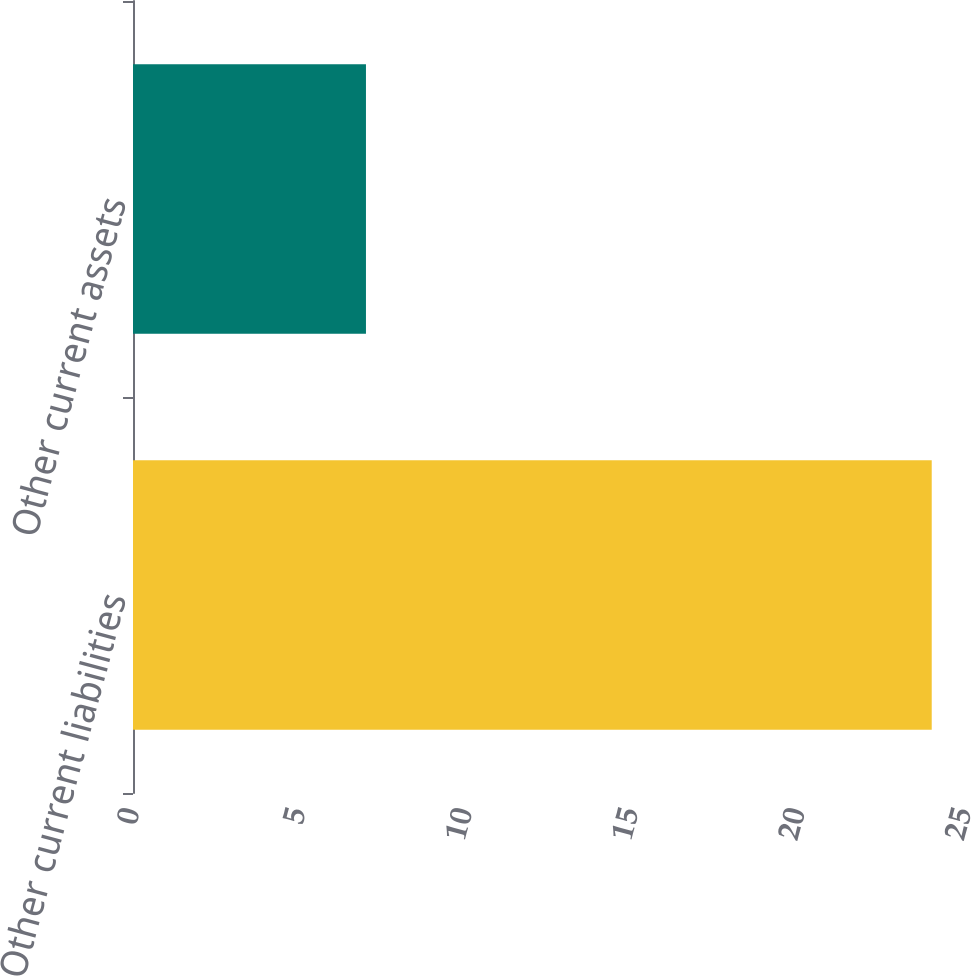Convert chart to OTSL. <chart><loc_0><loc_0><loc_500><loc_500><bar_chart><fcel>Other current liabilities<fcel>Other current assets<nl><fcel>24<fcel>7<nl></chart> 